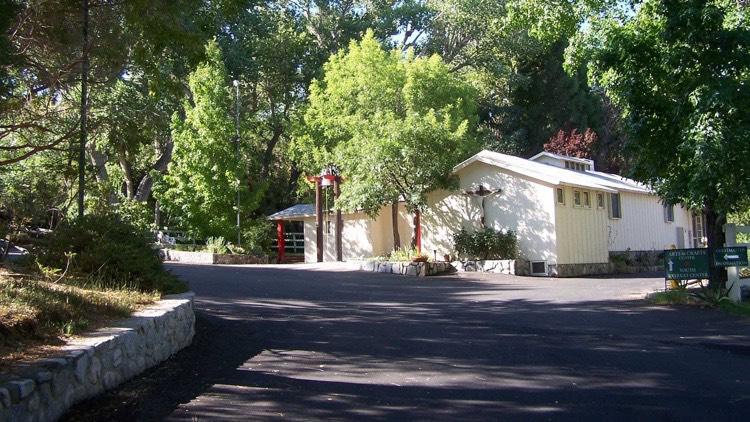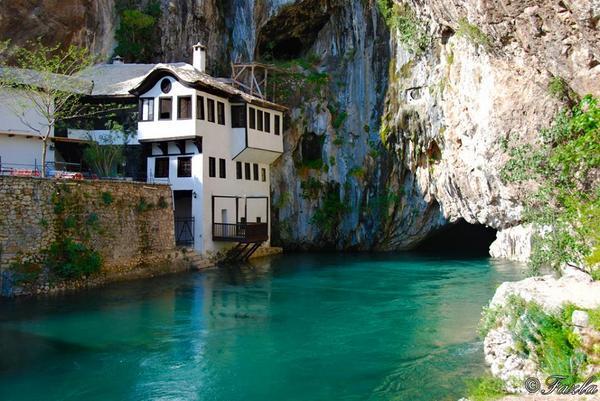The first image is the image on the left, the second image is the image on the right. Evaluate the accuracy of this statement regarding the images: "The house on the left has at least one arch shape around a window or door.". Is it true? Answer yes or no. No. 